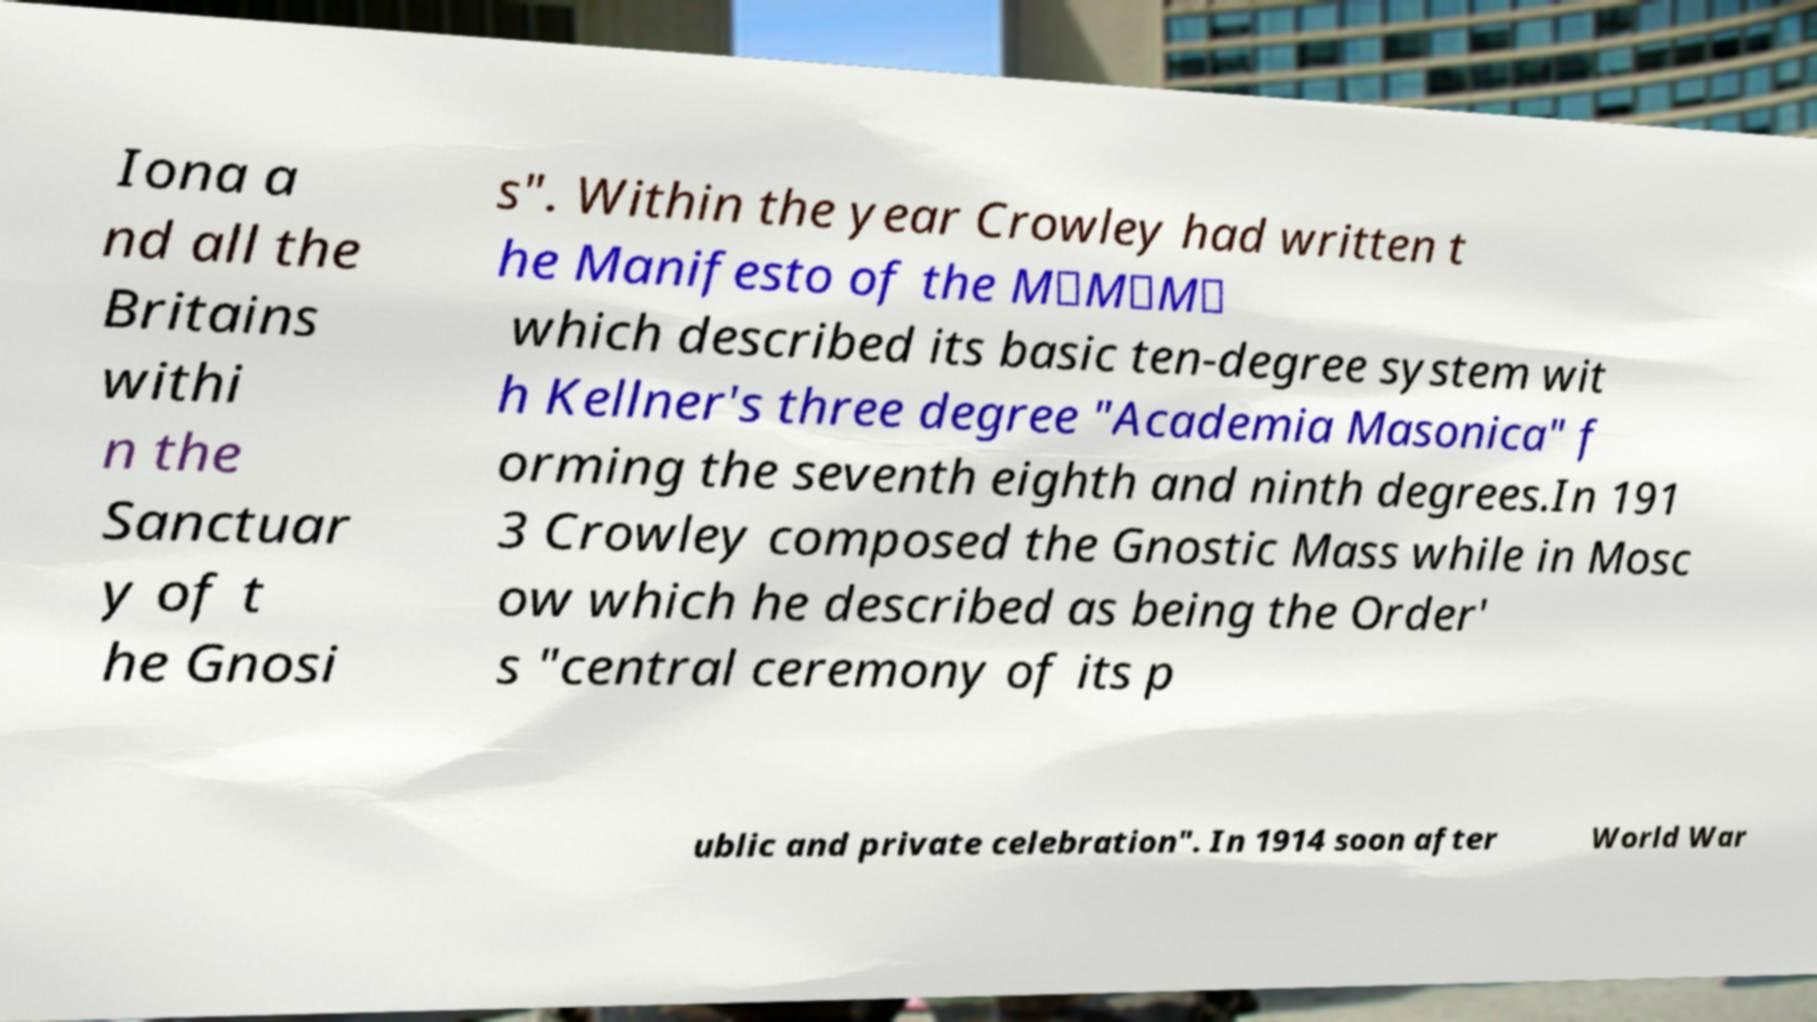Can you read and provide the text displayed in the image?This photo seems to have some interesting text. Can you extract and type it out for me? Iona a nd all the Britains withi n the Sanctuar y of t he Gnosi s". Within the year Crowley had written t he Manifesto of the M∴M∴M∴ which described its basic ten-degree system wit h Kellner's three degree "Academia Masonica" f orming the seventh eighth and ninth degrees.In 191 3 Crowley composed the Gnostic Mass while in Mosc ow which he described as being the Order' s "central ceremony of its p ublic and private celebration". In 1914 soon after World War 